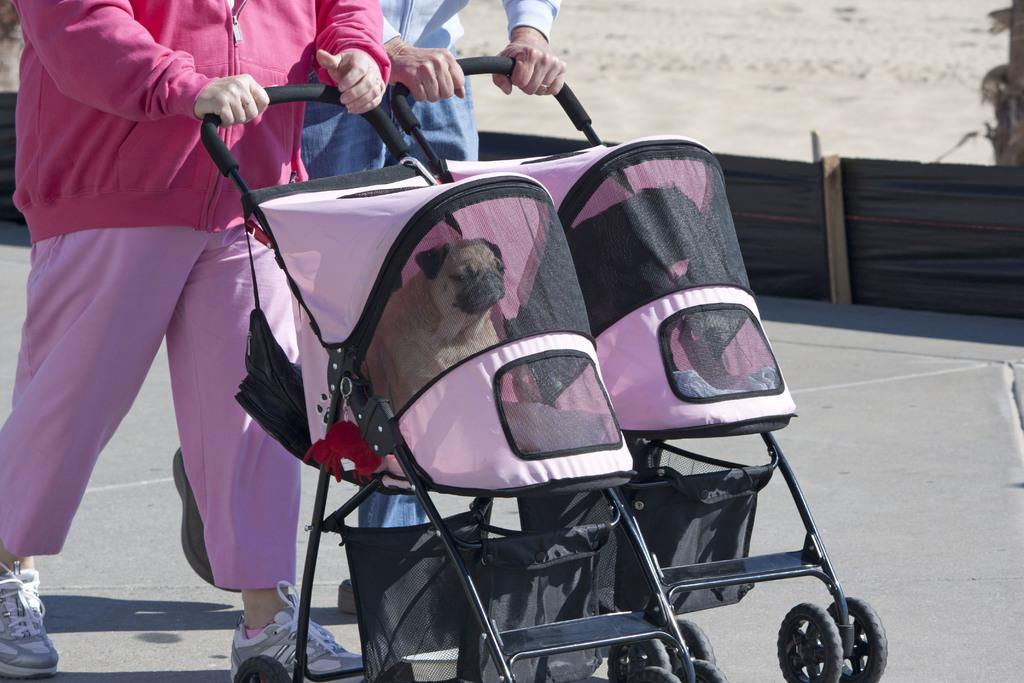Who or what is present in the image? There are people in the image. What are the people doing in the image? The people are holding the handle of a chair and walking on a road. What can be seen in the background of the image? There is a net visible in the image, and dogs are visible through the net. What type of record can be seen being played in the image? There is no record present in the image. How many bikes are visible in the image? There are no bikes visible in the image. 